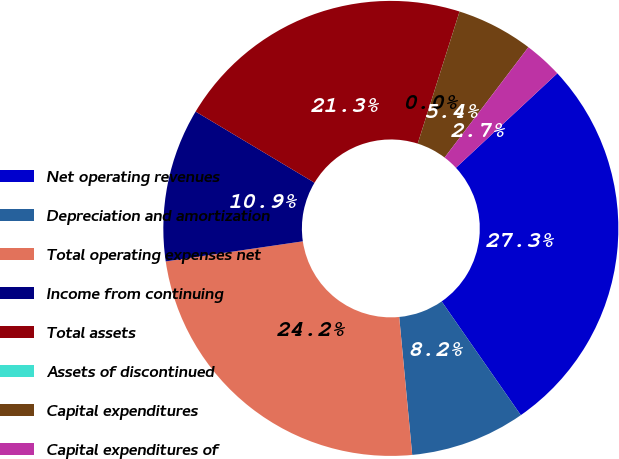<chart> <loc_0><loc_0><loc_500><loc_500><pie_chart><fcel>Net operating revenues<fcel>Depreciation and amortization<fcel>Total operating expenses net<fcel>Income from continuing<fcel>Total assets<fcel>Assets of discontinued<fcel>Capital expenditures<fcel>Capital expenditures of<nl><fcel>27.26%<fcel>8.18%<fcel>24.18%<fcel>10.9%<fcel>21.3%<fcel>0.0%<fcel>5.45%<fcel>2.73%<nl></chart> 